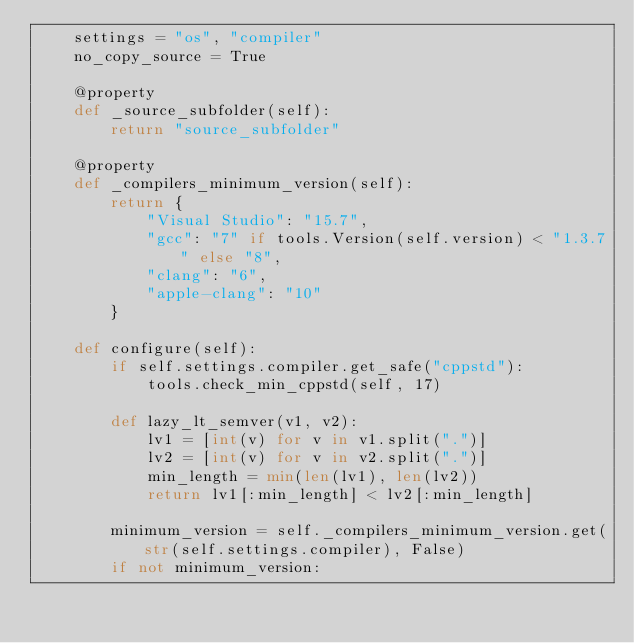<code> <loc_0><loc_0><loc_500><loc_500><_Python_>    settings = "os", "compiler"
    no_copy_source = True

    @property
    def _source_subfolder(self):
        return "source_subfolder"

    @property
    def _compilers_minimum_version(self):
        return {
            "Visual Studio": "15.7",
            "gcc": "7" if tools.Version(self.version) < "1.3.7" else "8",
            "clang": "6",
            "apple-clang": "10"
        }

    def configure(self):
        if self.settings.compiler.get_safe("cppstd"):
            tools.check_min_cppstd(self, 17)

        def lazy_lt_semver(v1, v2):
            lv1 = [int(v) for v in v1.split(".")]
            lv2 = [int(v) for v in v2.split(".")]
            min_length = min(len(lv1), len(lv2))
            return lv1[:min_length] < lv2[:min_length]

        minimum_version = self._compilers_minimum_version.get(str(self.settings.compiler), False)
        if not minimum_version:</code> 